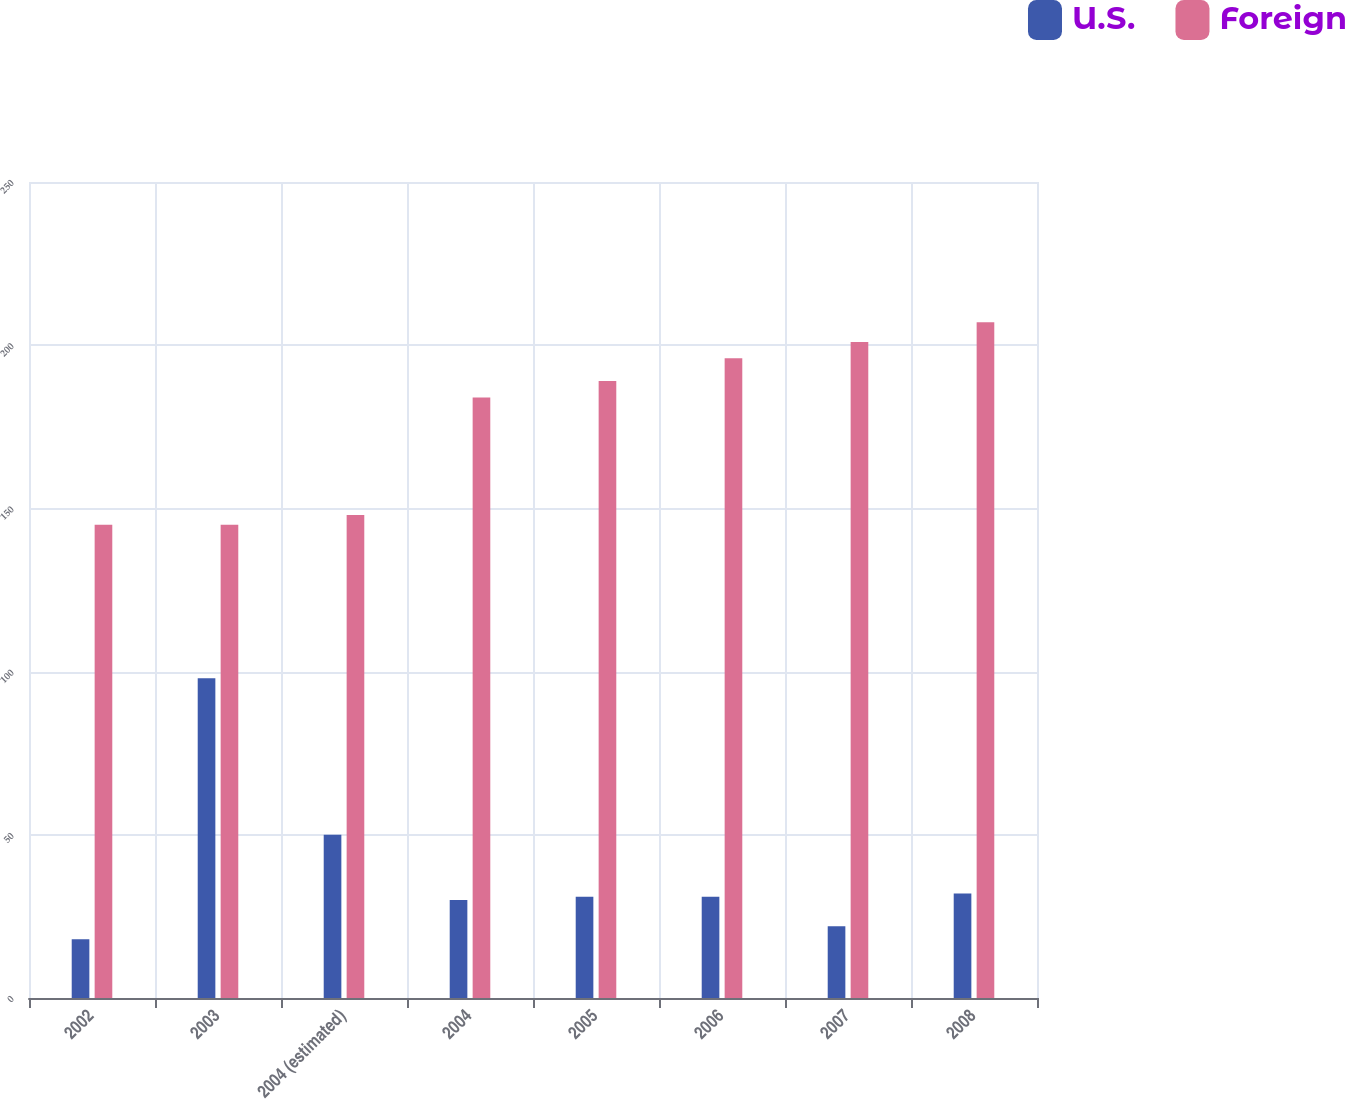<chart> <loc_0><loc_0><loc_500><loc_500><stacked_bar_chart><ecel><fcel>2002<fcel>2003<fcel>2004 (estimated)<fcel>2004<fcel>2005<fcel>2006<fcel>2007<fcel>2008<nl><fcel>U.S.<fcel>18<fcel>98<fcel>50<fcel>30<fcel>31<fcel>31<fcel>22<fcel>32<nl><fcel>Foreign<fcel>145<fcel>145<fcel>148<fcel>184<fcel>189<fcel>196<fcel>201<fcel>207<nl></chart> 